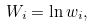Convert formula to latex. <formula><loc_0><loc_0><loc_500><loc_500>W _ { i } = \ln w _ { i } ,</formula> 